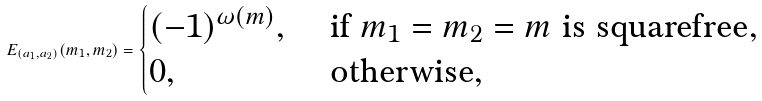<formula> <loc_0><loc_0><loc_500><loc_500>E _ { ( a _ { 1 } , a _ { 2 } ) } ( m _ { 1 } , m _ { 2 } ) = \begin{cases} ( - 1 ) ^ { \omega ( m ) } , & \text { if} \ m _ { 1 } = m _ { 2 } = m \text { is squarefree} , \\ 0 , & \text { otherwise} , \end{cases}</formula> 